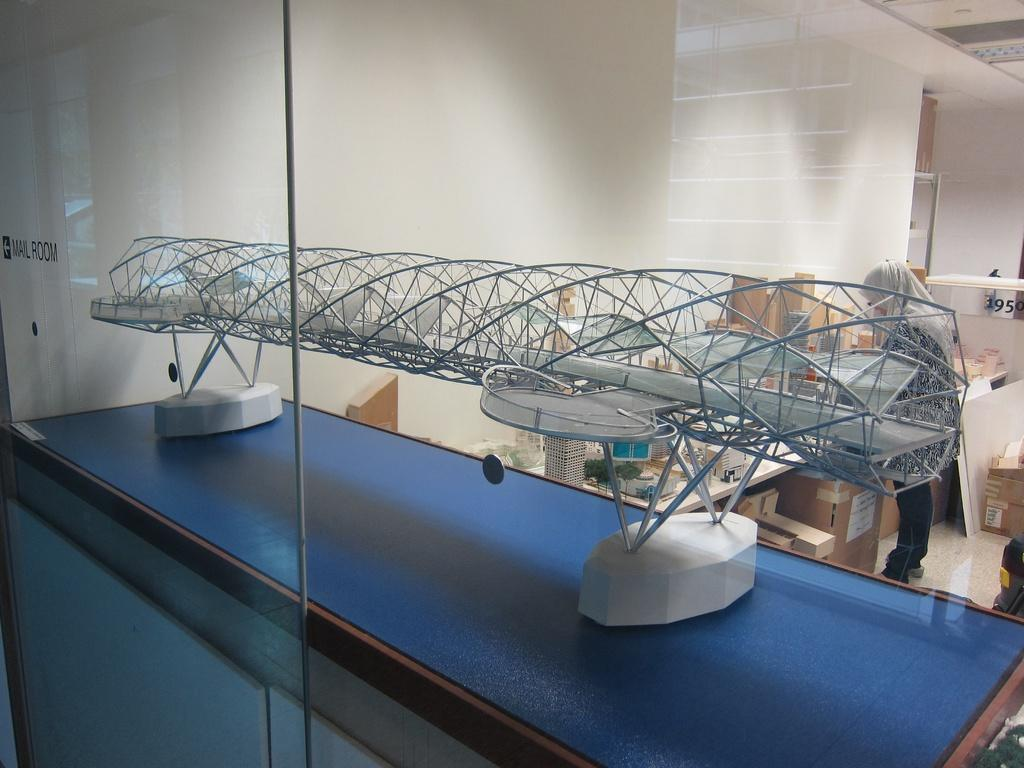What color is the table in the image? The table in the image is blue. What is on the blue table? A project of a bridge is present on the table. What can be seen in the background of the image? There are cardboard boxes, a person, another table, walls, and other unspecified things in the background of the image. What else is present on the blue table? There is a number board in the image. What grade is the person in the image teaching? There is no indication in the image that the person is teaching, nor is there any information about a grade. 